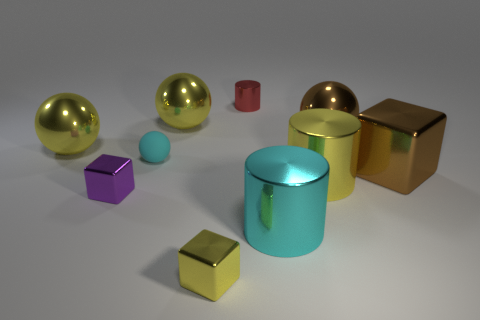What color is the large cube?
Ensure brevity in your answer.  Brown. There is a cyan object that is behind the yellow metallic cylinder; what shape is it?
Your response must be concise. Sphere. What number of purple objects are either tiny blocks or cubes?
Your answer should be compact. 1. The other tiny block that is made of the same material as the small purple cube is what color?
Provide a short and direct response. Yellow. There is a small matte thing; does it have the same color as the block right of the tiny yellow object?
Provide a succinct answer. No. The metallic object that is both on the right side of the small yellow thing and on the left side of the large cyan shiny thing is what color?
Your response must be concise. Red. What number of cyan metallic cylinders are in front of the cyan metallic object?
Your response must be concise. 0. How many objects are either red cylinders or objects behind the big brown metal cube?
Your answer should be very brief. 5. Are there any small rubber objects behind the cyan matte thing that is behind the large cyan shiny thing?
Your answer should be very brief. No. What is the color of the cube that is on the right side of the tiny red cylinder?
Your answer should be very brief. Brown. 